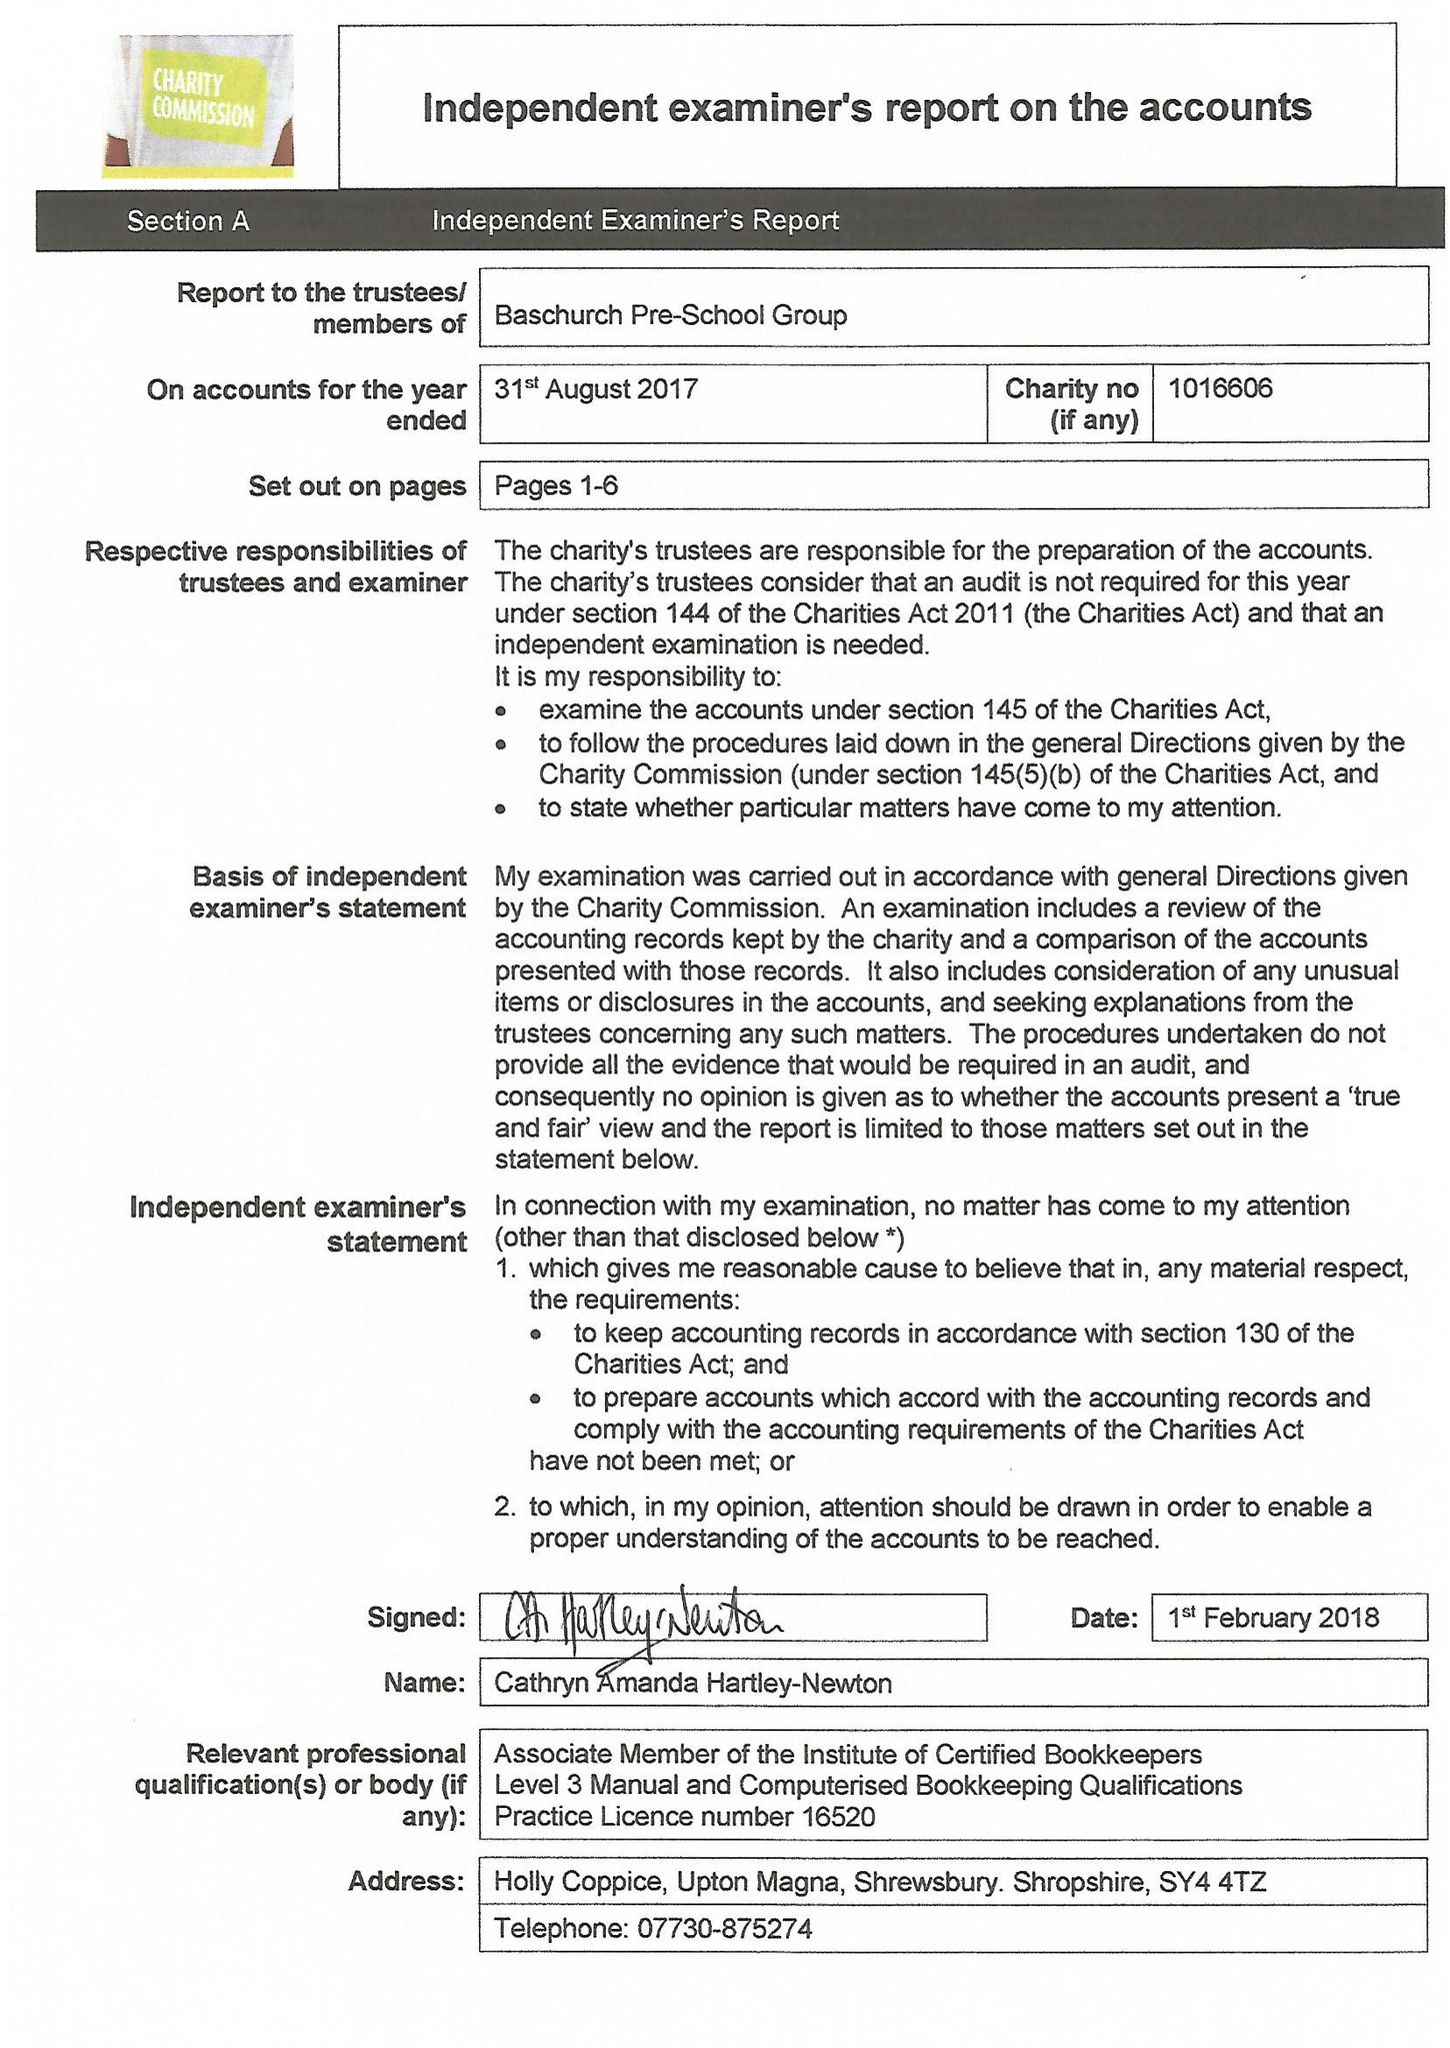What is the value for the charity_name?
Answer the question using a single word or phrase. Baschurch Pre School Group 